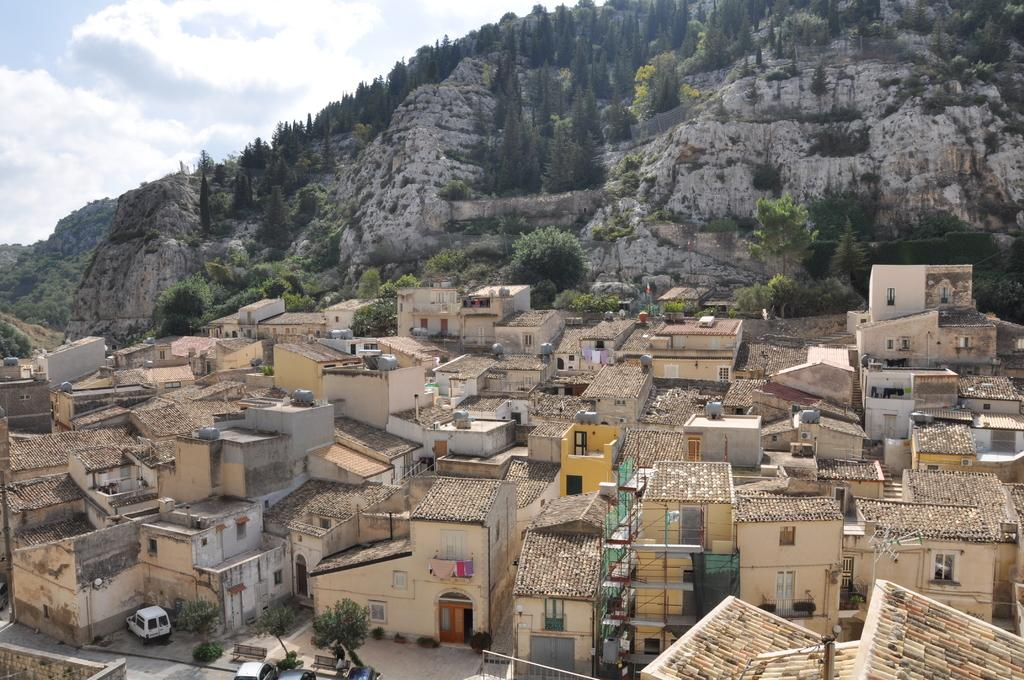What type of structures can be seen in the image? There are houses in the image. What other natural elements are present in the image? There are trees and a mountain in the image. What is visible in the background of the image? The sky is visible in the background of the image. What can be seen in the sky? Clouds are present in the sky. What type of rock is being used to build the houses in the image? There is no information about the type of rock used to build the houses in the image. 